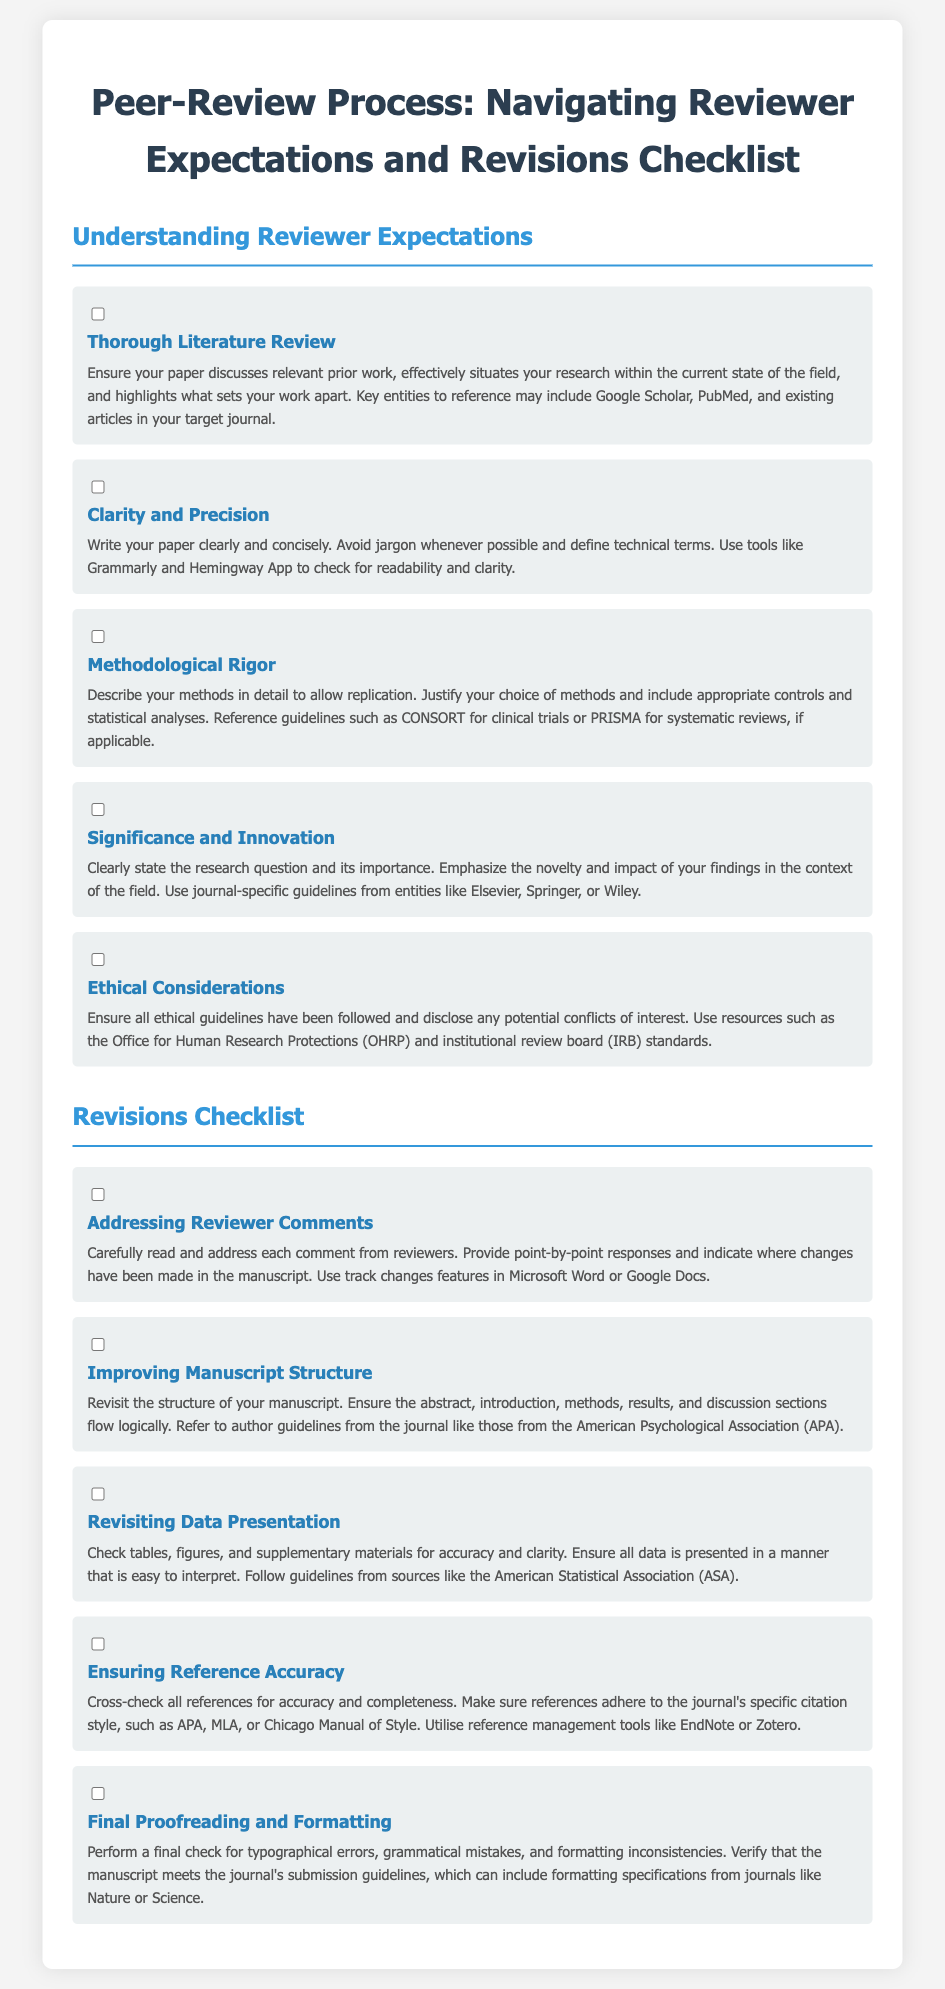What is the first item in the "Understanding Reviewer Expectations" section? The first item is a thorough literature review, which emphasizes discussing relevant prior work.
Answer: Thorough Literature Review What is the purpose of the "Clarity and Precision" item? This item encourages writing the paper clearly and concisely while avoiding jargon.
Answer: Write clearly and concisely Which resources are suggested for ethical considerations? The suggested resources include the Office for Human Research Protections and institutional review board standards.
Answer: OHRP and IRB What should be included in addressing reviewer comments? Reviewer comments should be read and addressed point-by-point, indicating where changes have been made.
Answer: Point-by-point responses What is one guideline to improve manuscript structure? Authors are advised to refer to author guidelines from the American Psychological Association.
Answer: APA guidelines How many items are included in the "Revisions Checklist"? The "Revisions Checklist" contains five items, each focusing on different revision areas.
Answer: Five items What is the last item in the checklist focusing on? The last item focuses on performing final proofreading and formatting checks.
Answer: Final proofreading and formatting Which tool is suggested for ensuring reference accuracy? Reference management tools like EndNote or Zotero are recommended for accuracy.
Answer: EndNote or Zotero What is the emphasis of the "Significance and Innovation" item? This item emphasizes clearly stating the research question and its importance.
Answer: Research question and importance 